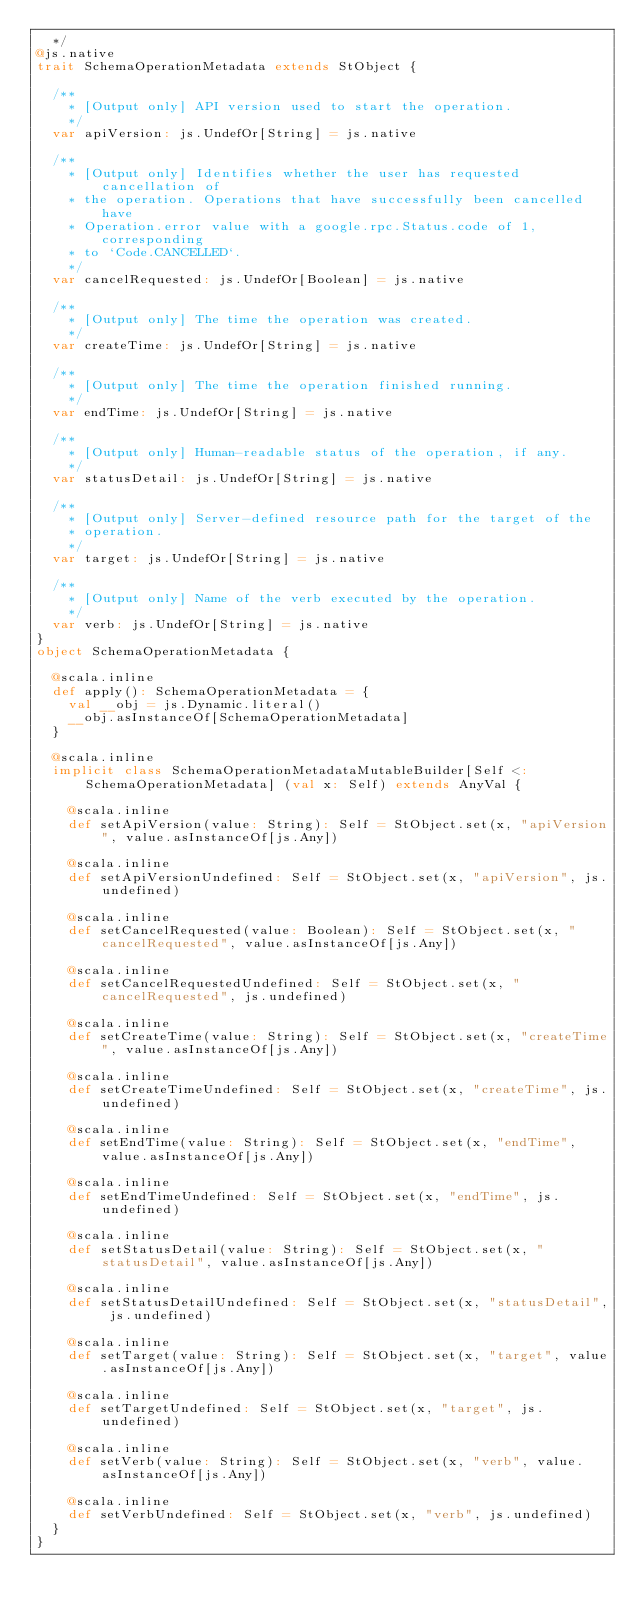Convert code to text. <code><loc_0><loc_0><loc_500><loc_500><_Scala_>  */
@js.native
trait SchemaOperationMetadata extends StObject {
  
  /**
    * [Output only] API version used to start the operation.
    */
  var apiVersion: js.UndefOr[String] = js.native
  
  /**
    * [Output only] Identifies whether the user has requested cancellation of
    * the operation. Operations that have successfully been cancelled have
    * Operation.error value with a google.rpc.Status.code of 1, corresponding
    * to `Code.CANCELLED`.
    */
  var cancelRequested: js.UndefOr[Boolean] = js.native
  
  /**
    * [Output only] The time the operation was created.
    */
  var createTime: js.UndefOr[String] = js.native
  
  /**
    * [Output only] The time the operation finished running.
    */
  var endTime: js.UndefOr[String] = js.native
  
  /**
    * [Output only] Human-readable status of the operation, if any.
    */
  var statusDetail: js.UndefOr[String] = js.native
  
  /**
    * [Output only] Server-defined resource path for the target of the
    * operation.
    */
  var target: js.UndefOr[String] = js.native
  
  /**
    * [Output only] Name of the verb executed by the operation.
    */
  var verb: js.UndefOr[String] = js.native
}
object SchemaOperationMetadata {
  
  @scala.inline
  def apply(): SchemaOperationMetadata = {
    val __obj = js.Dynamic.literal()
    __obj.asInstanceOf[SchemaOperationMetadata]
  }
  
  @scala.inline
  implicit class SchemaOperationMetadataMutableBuilder[Self <: SchemaOperationMetadata] (val x: Self) extends AnyVal {
    
    @scala.inline
    def setApiVersion(value: String): Self = StObject.set(x, "apiVersion", value.asInstanceOf[js.Any])
    
    @scala.inline
    def setApiVersionUndefined: Self = StObject.set(x, "apiVersion", js.undefined)
    
    @scala.inline
    def setCancelRequested(value: Boolean): Self = StObject.set(x, "cancelRequested", value.asInstanceOf[js.Any])
    
    @scala.inline
    def setCancelRequestedUndefined: Self = StObject.set(x, "cancelRequested", js.undefined)
    
    @scala.inline
    def setCreateTime(value: String): Self = StObject.set(x, "createTime", value.asInstanceOf[js.Any])
    
    @scala.inline
    def setCreateTimeUndefined: Self = StObject.set(x, "createTime", js.undefined)
    
    @scala.inline
    def setEndTime(value: String): Self = StObject.set(x, "endTime", value.asInstanceOf[js.Any])
    
    @scala.inline
    def setEndTimeUndefined: Self = StObject.set(x, "endTime", js.undefined)
    
    @scala.inline
    def setStatusDetail(value: String): Self = StObject.set(x, "statusDetail", value.asInstanceOf[js.Any])
    
    @scala.inline
    def setStatusDetailUndefined: Self = StObject.set(x, "statusDetail", js.undefined)
    
    @scala.inline
    def setTarget(value: String): Self = StObject.set(x, "target", value.asInstanceOf[js.Any])
    
    @scala.inline
    def setTargetUndefined: Self = StObject.set(x, "target", js.undefined)
    
    @scala.inline
    def setVerb(value: String): Self = StObject.set(x, "verb", value.asInstanceOf[js.Any])
    
    @scala.inline
    def setVerbUndefined: Self = StObject.set(x, "verb", js.undefined)
  }
}
</code> 